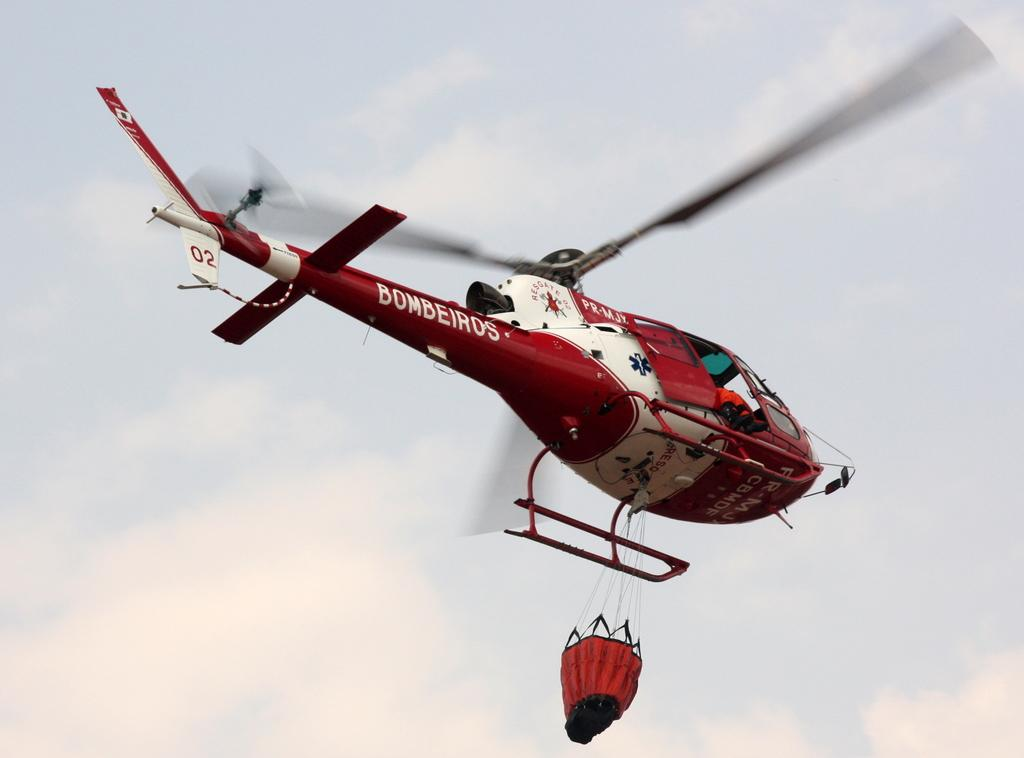What is the main subject of the image? The main subject of the image is a helicopter. What is the helicopter doing in the image? The helicopter is flying in the image. What is the condition of the sky in the image? The sky is cloudy in the image. What type of scarf is the father wearing in the image? There is no father or scarf present in the image; it features a helicopter flying in a cloudy sky. 